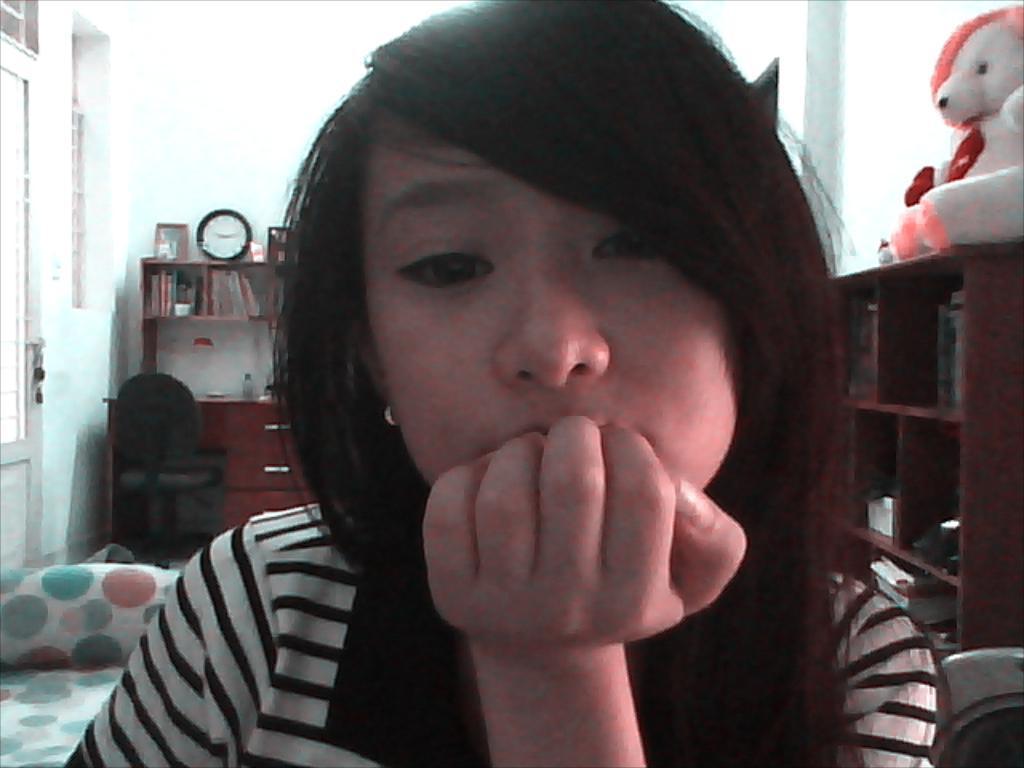How would you summarize this image in a sentence or two? In this image I can see the person and the person is wearing white and black color shirt. Background I can see the doll in white color and I can also see few books in the racks and I can also see the chair. Background the wall is in white color. 